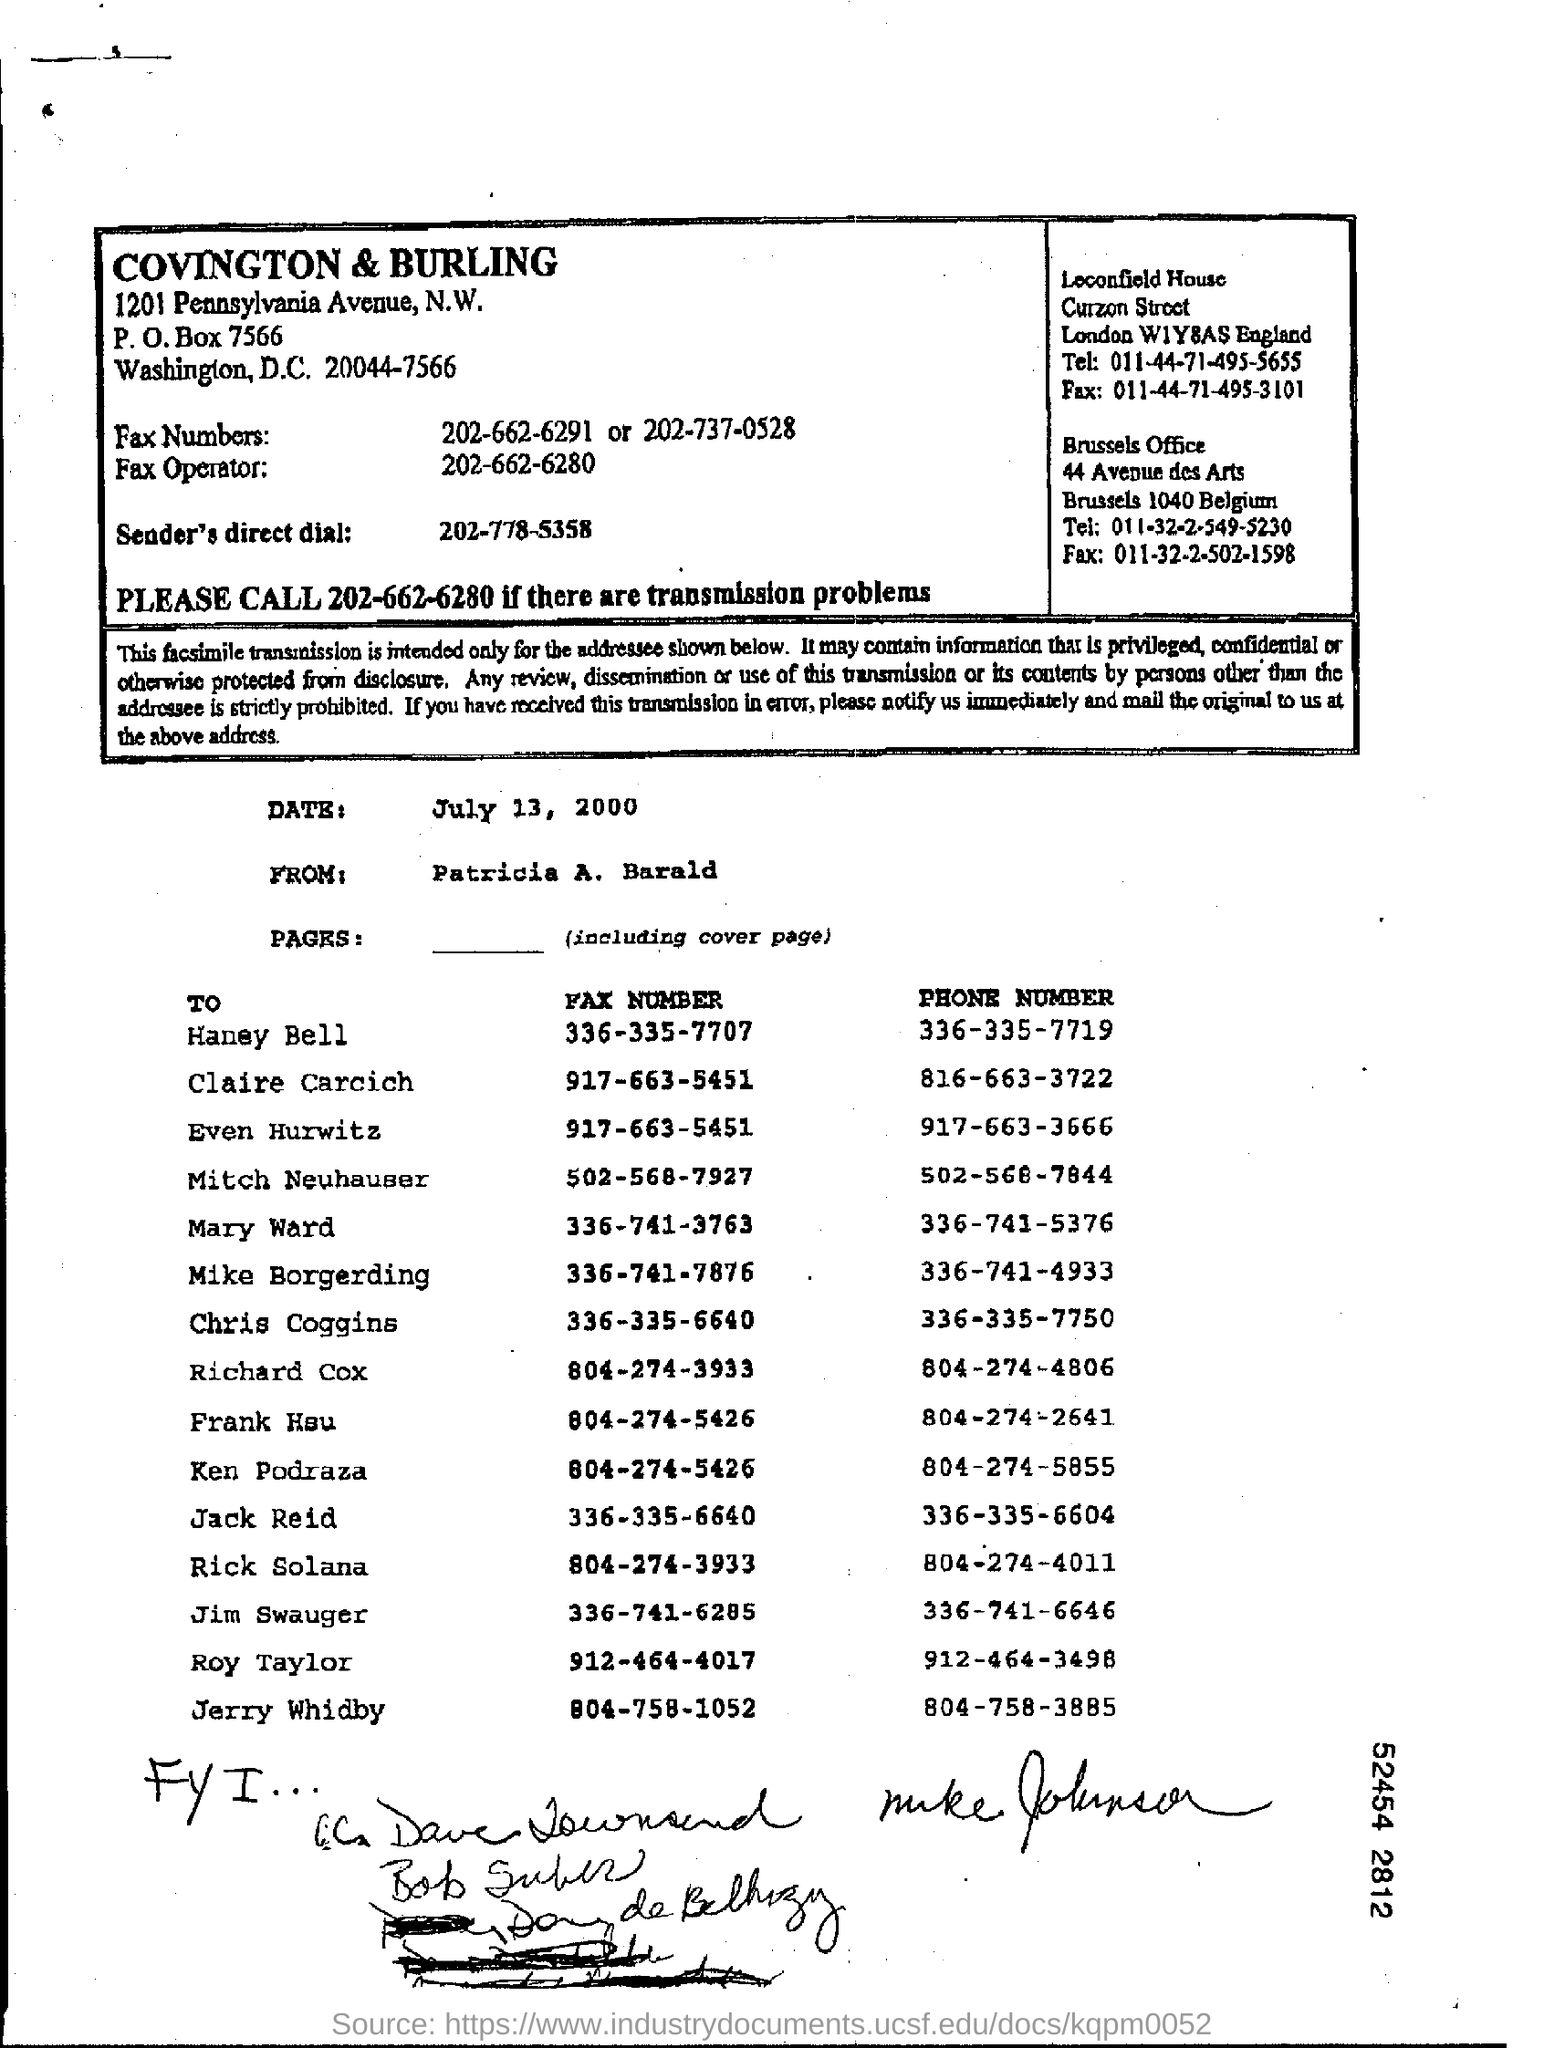What is the date mentioned?
Your answer should be compact. July 13, 2000. Fax number of Haney Bell?
Your response must be concise. 336-335-7707. Phone number of Haney Bell?
Your answer should be very brief. 336-335-7719. 